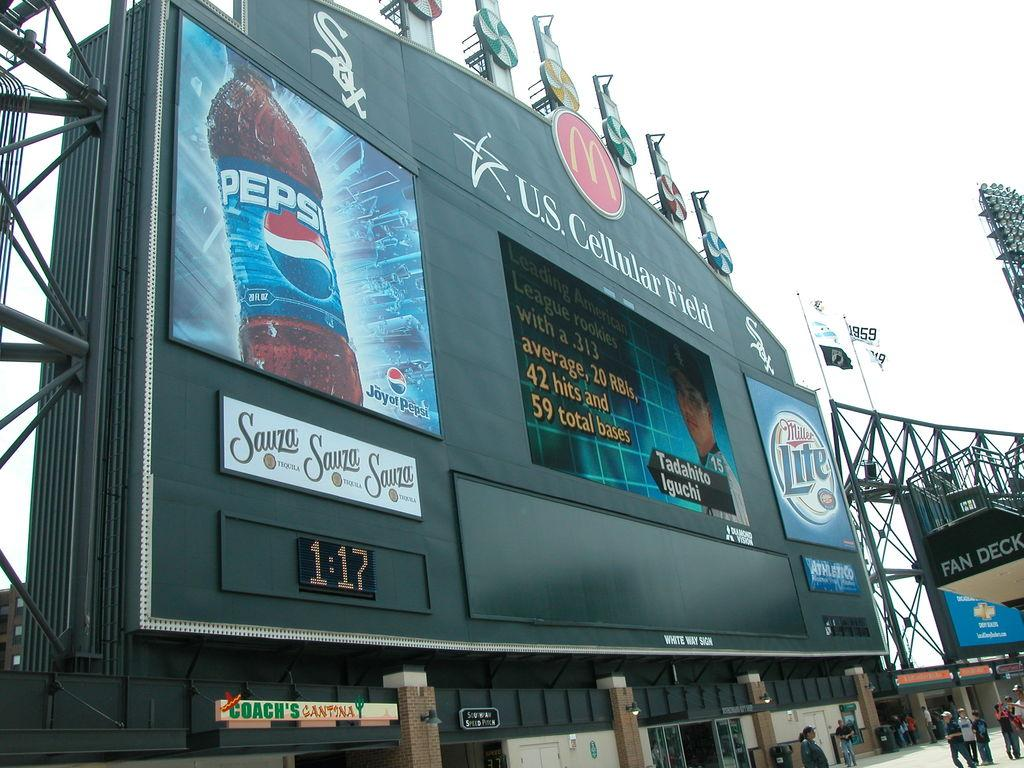<image>
Write a terse but informative summary of the picture. A large score board for a ball g ame with the pepsi logo prominently displayed on the left. 